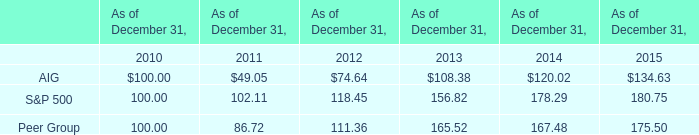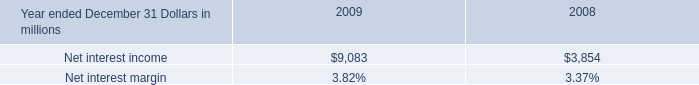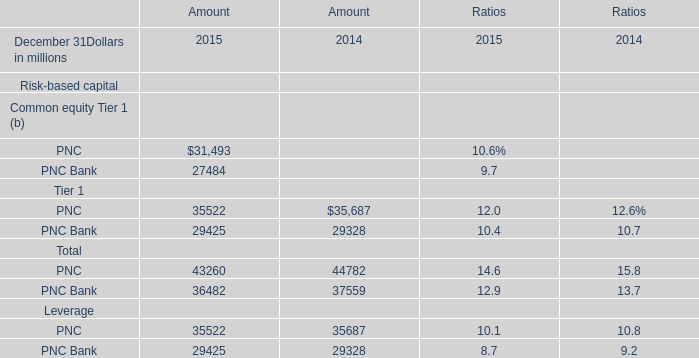What is the total amount of Net interest income of 2009, PNC Bank of Amount 2015, and PNC Bank Total of Amount 2015 ? 
Computations: ((9083.0 + 27484.0) + 36482.0)
Answer: 73049.0. 